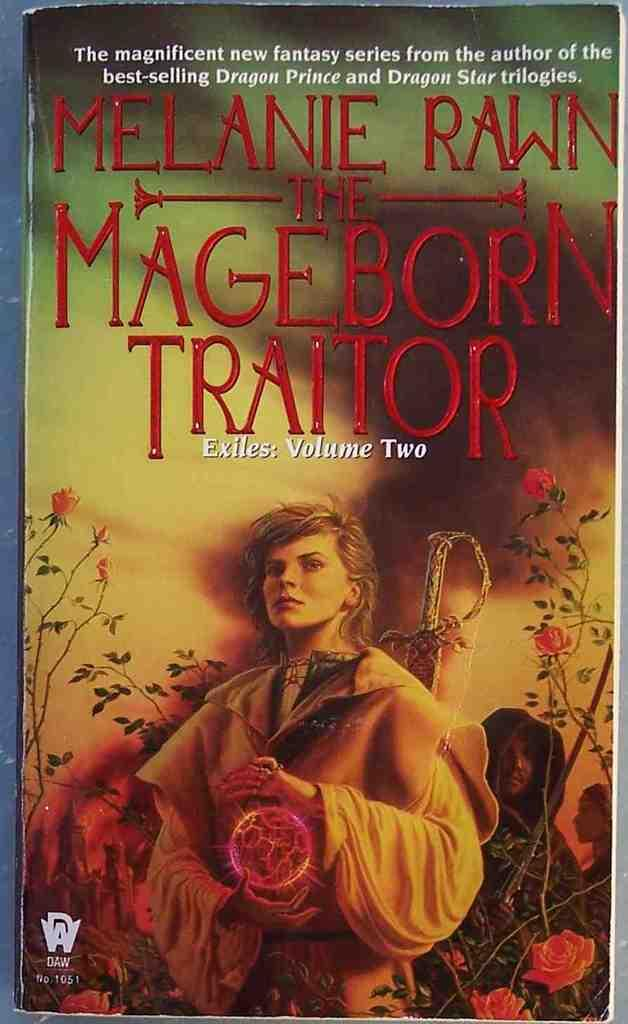What is the main subject of the image? The main subject of the image is the cover page of a book. What can be found on the cover page? There is text and images on the cover page. What type of rhythm can be heard coming from the party in the image? There is no party present in the image, so it's not possible to determine what, if any, rhythm might be heard. 